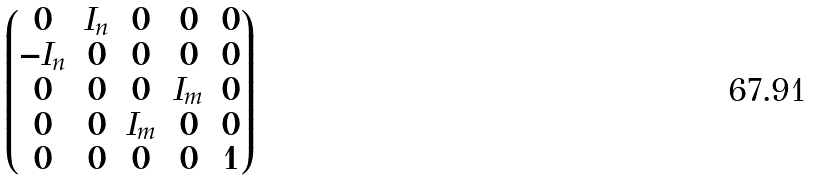<formula> <loc_0><loc_0><loc_500><loc_500>\begin{pmatrix} 0 & I _ { n } & 0 & 0 & 0 \\ - I _ { n } & 0 & 0 & 0 & 0 \\ 0 & 0 & 0 & I _ { m } & 0 \\ 0 & 0 & I _ { m } & 0 & 0 \\ 0 & 0 & 0 & 0 & 1 \end{pmatrix}</formula> 